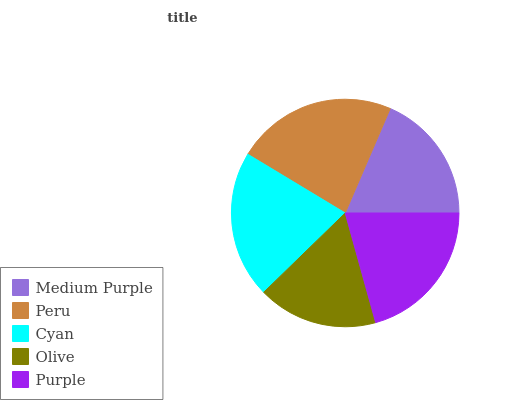Is Olive the minimum?
Answer yes or no. Yes. Is Peru the maximum?
Answer yes or no. Yes. Is Cyan the minimum?
Answer yes or no. No. Is Cyan the maximum?
Answer yes or no. No. Is Peru greater than Cyan?
Answer yes or no. Yes. Is Cyan less than Peru?
Answer yes or no. Yes. Is Cyan greater than Peru?
Answer yes or no. No. Is Peru less than Cyan?
Answer yes or no. No. Is Purple the high median?
Answer yes or no. Yes. Is Purple the low median?
Answer yes or no. Yes. Is Medium Purple the high median?
Answer yes or no. No. Is Cyan the low median?
Answer yes or no. No. 